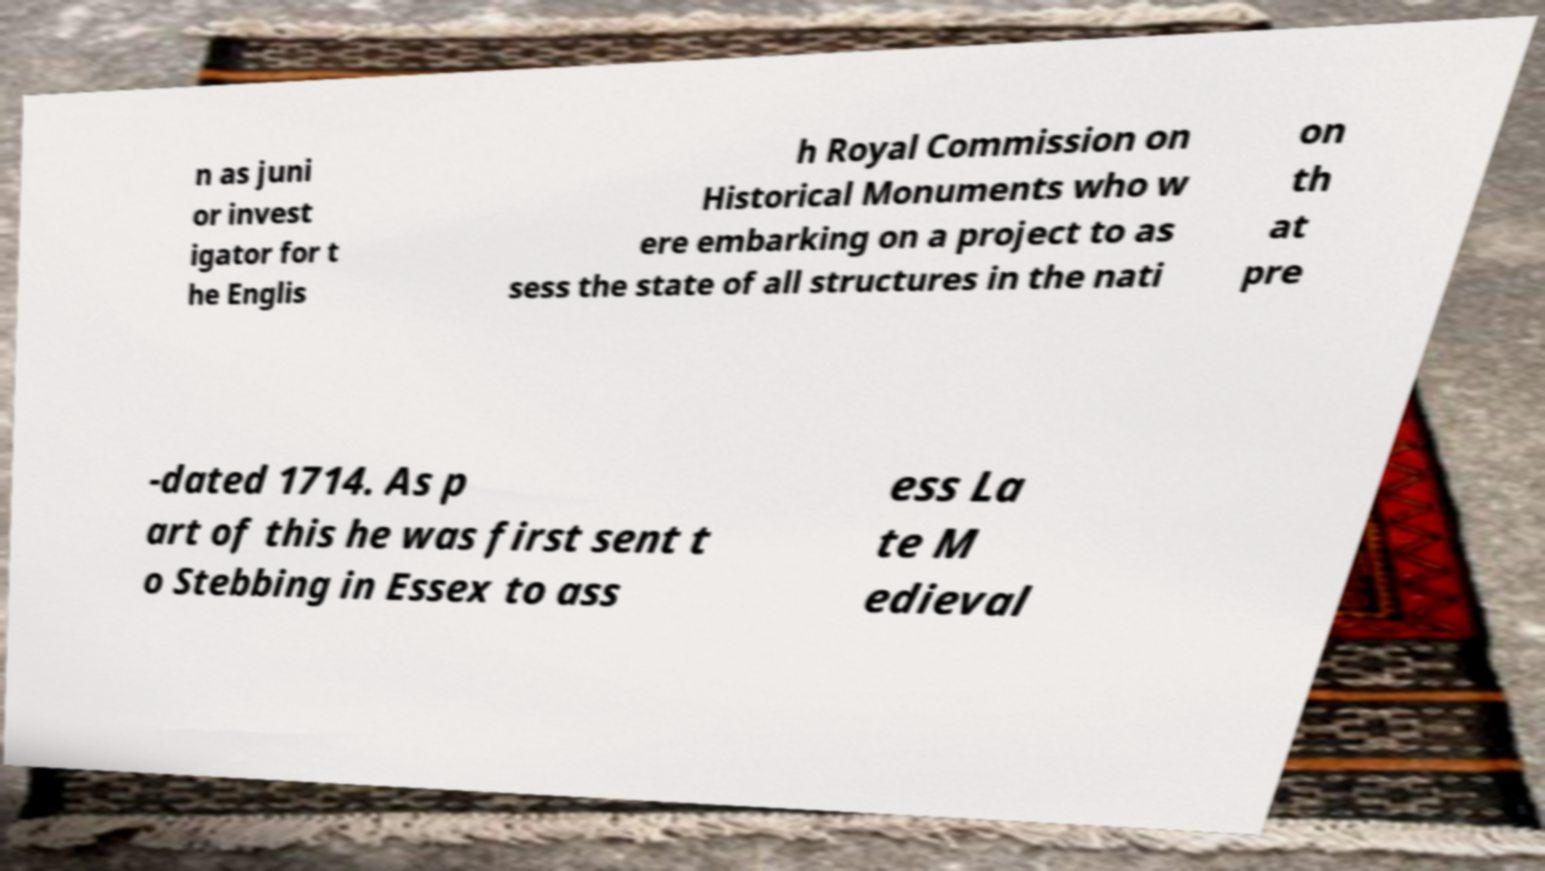Can you accurately transcribe the text from the provided image for me? n as juni or invest igator for t he Englis h Royal Commission on Historical Monuments who w ere embarking on a project to as sess the state of all structures in the nati on th at pre -dated 1714. As p art of this he was first sent t o Stebbing in Essex to ass ess La te M edieval 